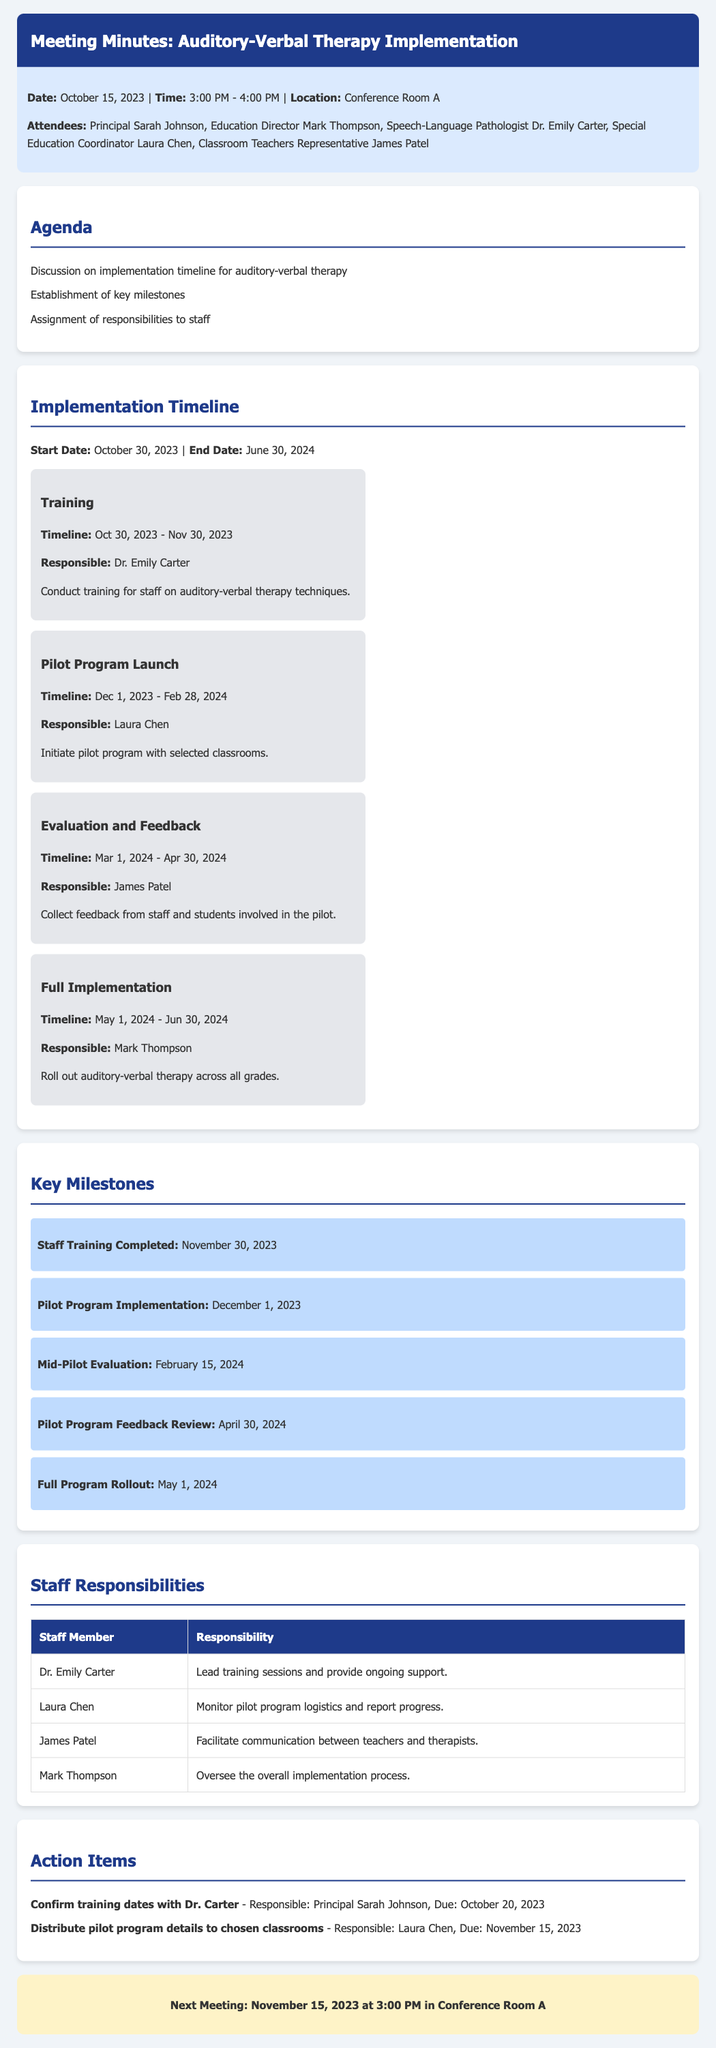What is the start date of the implementation? The start date of the implementation timeline is specified in the document as October 30, 2023.
Answer: October 30, 2023 Who is responsible for the training phase? The document states that Dr. Emily Carter is responsible for conducting training for staff on auditory-verbal therapy techniques.
Answer: Dr. Emily Carter When is the next meeting scheduled? The document indicates the next meeting is planned for November 15, 2023, at 3:00 PM.
Answer: November 15, 2023 What is the end date for the full implementation phase? The document specifies the end date for the full implementation phase as June 30, 2024.
Answer: June 30, 2024 Which milestone is due on February 15, 2024? The document lists the mid-pilot evaluation as the milestone due on February 15, 2024.
Answer: Mid-Pilot Evaluation How long is the training phase scheduled to last? The timeline in the document indicates that the training phase lasts from October 30, 2023, to November 30, 2023, which is 31 days.
Answer: 31 days What role does James Patel have in the implementation process? According to the document, James Patel's responsibility is to facilitate communication between teachers and therapists during the implementation.
Answer: Facilitate communication What is the purpose of the pilot program? The document states that the pilot program is intended to test auditory-verbal therapy techniques in selected classrooms.
Answer: Test techniques in selected classrooms 